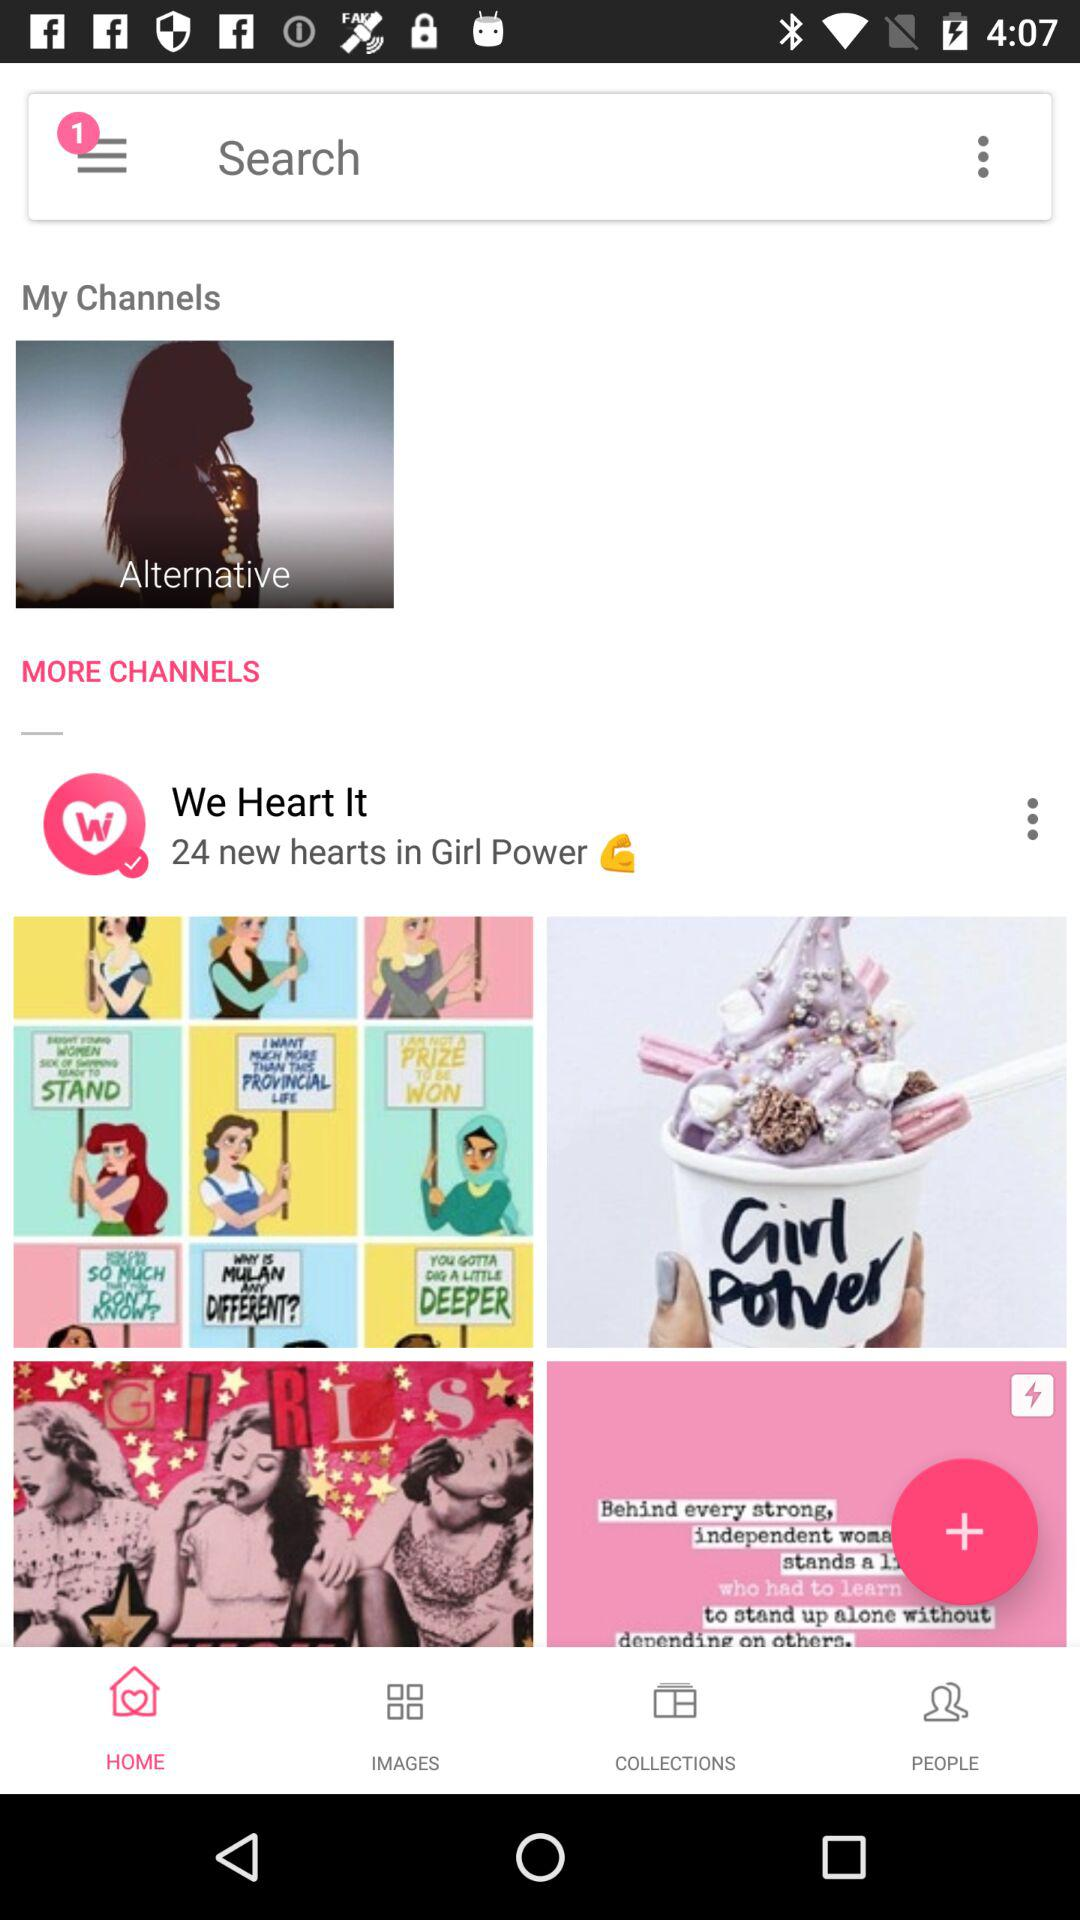How many hearts are in "Girl Power"? There are 24 new hearts in "Girl Power". 